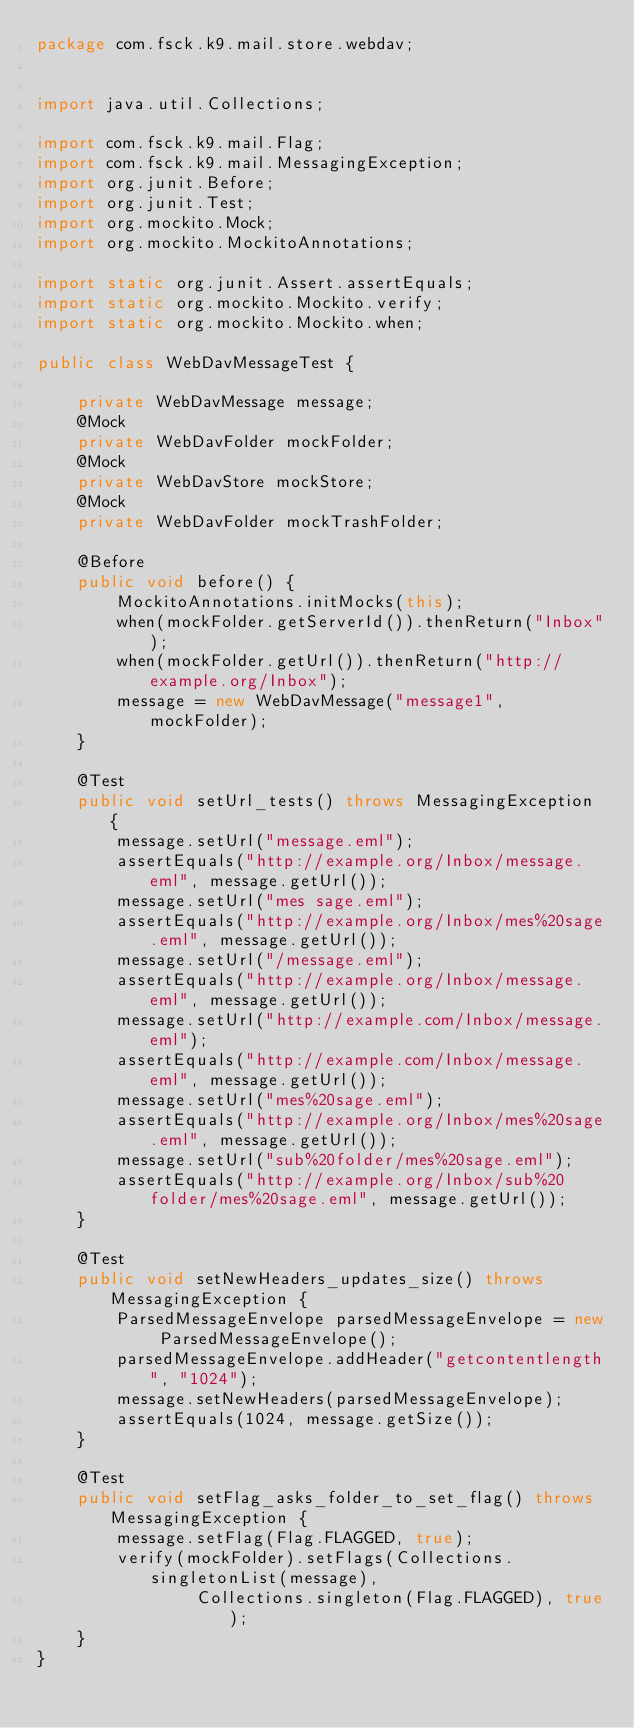Convert code to text. <code><loc_0><loc_0><loc_500><loc_500><_Java_>package com.fsck.k9.mail.store.webdav;


import java.util.Collections;

import com.fsck.k9.mail.Flag;
import com.fsck.k9.mail.MessagingException;
import org.junit.Before;
import org.junit.Test;
import org.mockito.Mock;
import org.mockito.MockitoAnnotations;

import static org.junit.Assert.assertEquals;
import static org.mockito.Mockito.verify;
import static org.mockito.Mockito.when;

public class WebDavMessageTest {

    private WebDavMessage message;
    @Mock
    private WebDavFolder mockFolder;
    @Mock
    private WebDavStore mockStore;
    @Mock
    private WebDavFolder mockTrashFolder;

    @Before
    public void before() {
        MockitoAnnotations.initMocks(this);
        when(mockFolder.getServerId()).thenReturn("Inbox");
        when(mockFolder.getUrl()).thenReturn("http://example.org/Inbox");
        message = new WebDavMessage("message1", mockFolder);
    }

    @Test
    public void setUrl_tests() throws MessagingException {
        message.setUrl("message.eml");
        assertEquals("http://example.org/Inbox/message.eml", message.getUrl());
        message.setUrl("mes sage.eml");
        assertEquals("http://example.org/Inbox/mes%20sage.eml", message.getUrl());
        message.setUrl("/message.eml");
        assertEquals("http://example.org/Inbox/message.eml", message.getUrl());
        message.setUrl("http://example.com/Inbox/message.eml");
        assertEquals("http://example.com/Inbox/message.eml", message.getUrl());
        message.setUrl("mes%20sage.eml");
        assertEquals("http://example.org/Inbox/mes%20sage.eml", message.getUrl());
        message.setUrl("sub%20folder/mes%20sage.eml");
        assertEquals("http://example.org/Inbox/sub%20folder/mes%20sage.eml", message.getUrl());
    }

    @Test
    public void setNewHeaders_updates_size() throws MessagingException {
        ParsedMessageEnvelope parsedMessageEnvelope = new ParsedMessageEnvelope();
        parsedMessageEnvelope.addHeader("getcontentlength", "1024");
        message.setNewHeaders(parsedMessageEnvelope);
        assertEquals(1024, message.getSize());
    }

    @Test
    public void setFlag_asks_folder_to_set_flag() throws MessagingException {
        message.setFlag(Flag.FLAGGED, true);
        verify(mockFolder).setFlags(Collections.singletonList(message),
                Collections.singleton(Flag.FLAGGED), true);
    }
}
</code> 